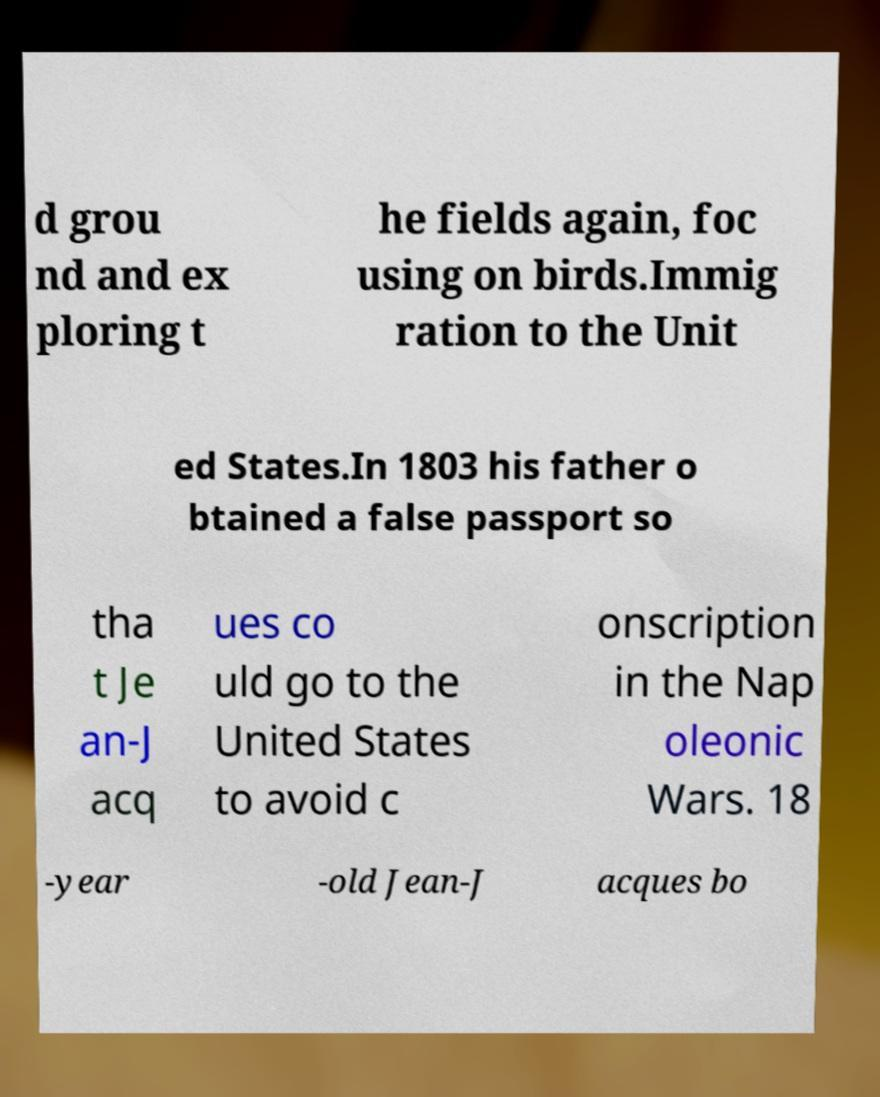Could you extract and type out the text from this image? d grou nd and ex ploring t he fields again, foc using on birds.Immig ration to the Unit ed States.In 1803 his father o btained a false passport so tha t Je an-J acq ues co uld go to the United States to avoid c onscription in the Nap oleonic Wars. 18 -year -old Jean-J acques bo 